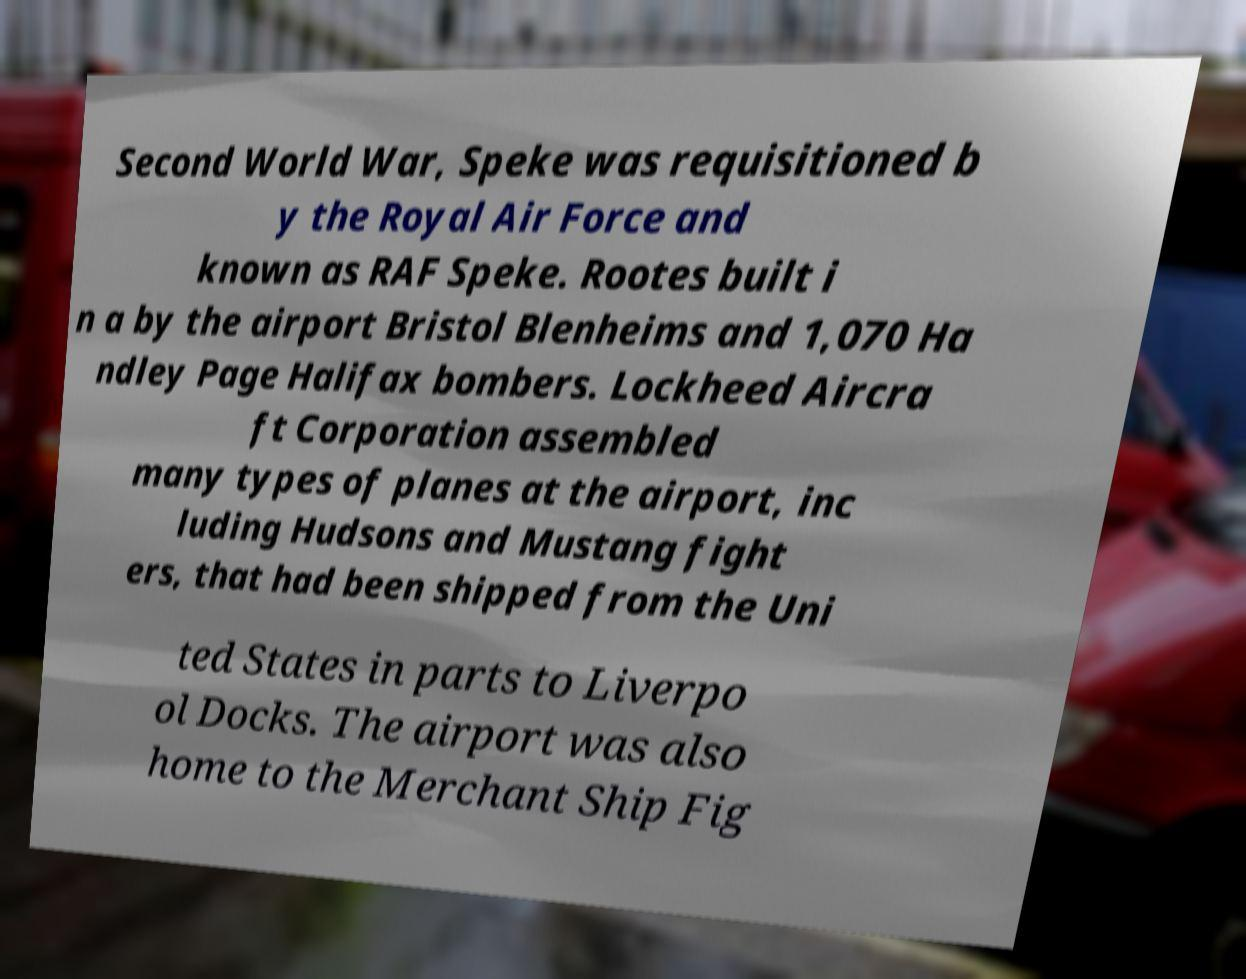There's text embedded in this image that I need extracted. Can you transcribe it verbatim? Second World War, Speke was requisitioned b y the Royal Air Force and known as RAF Speke. Rootes built i n a by the airport Bristol Blenheims and 1,070 Ha ndley Page Halifax bombers. Lockheed Aircra ft Corporation assembled many types of planes at the airport, inc luding Hudsons and Mustang fight ers, that had been shipped from the Uni ted States in parts to Liverpo ol Docks. The airport was also home to the Merchant Ship Fig 